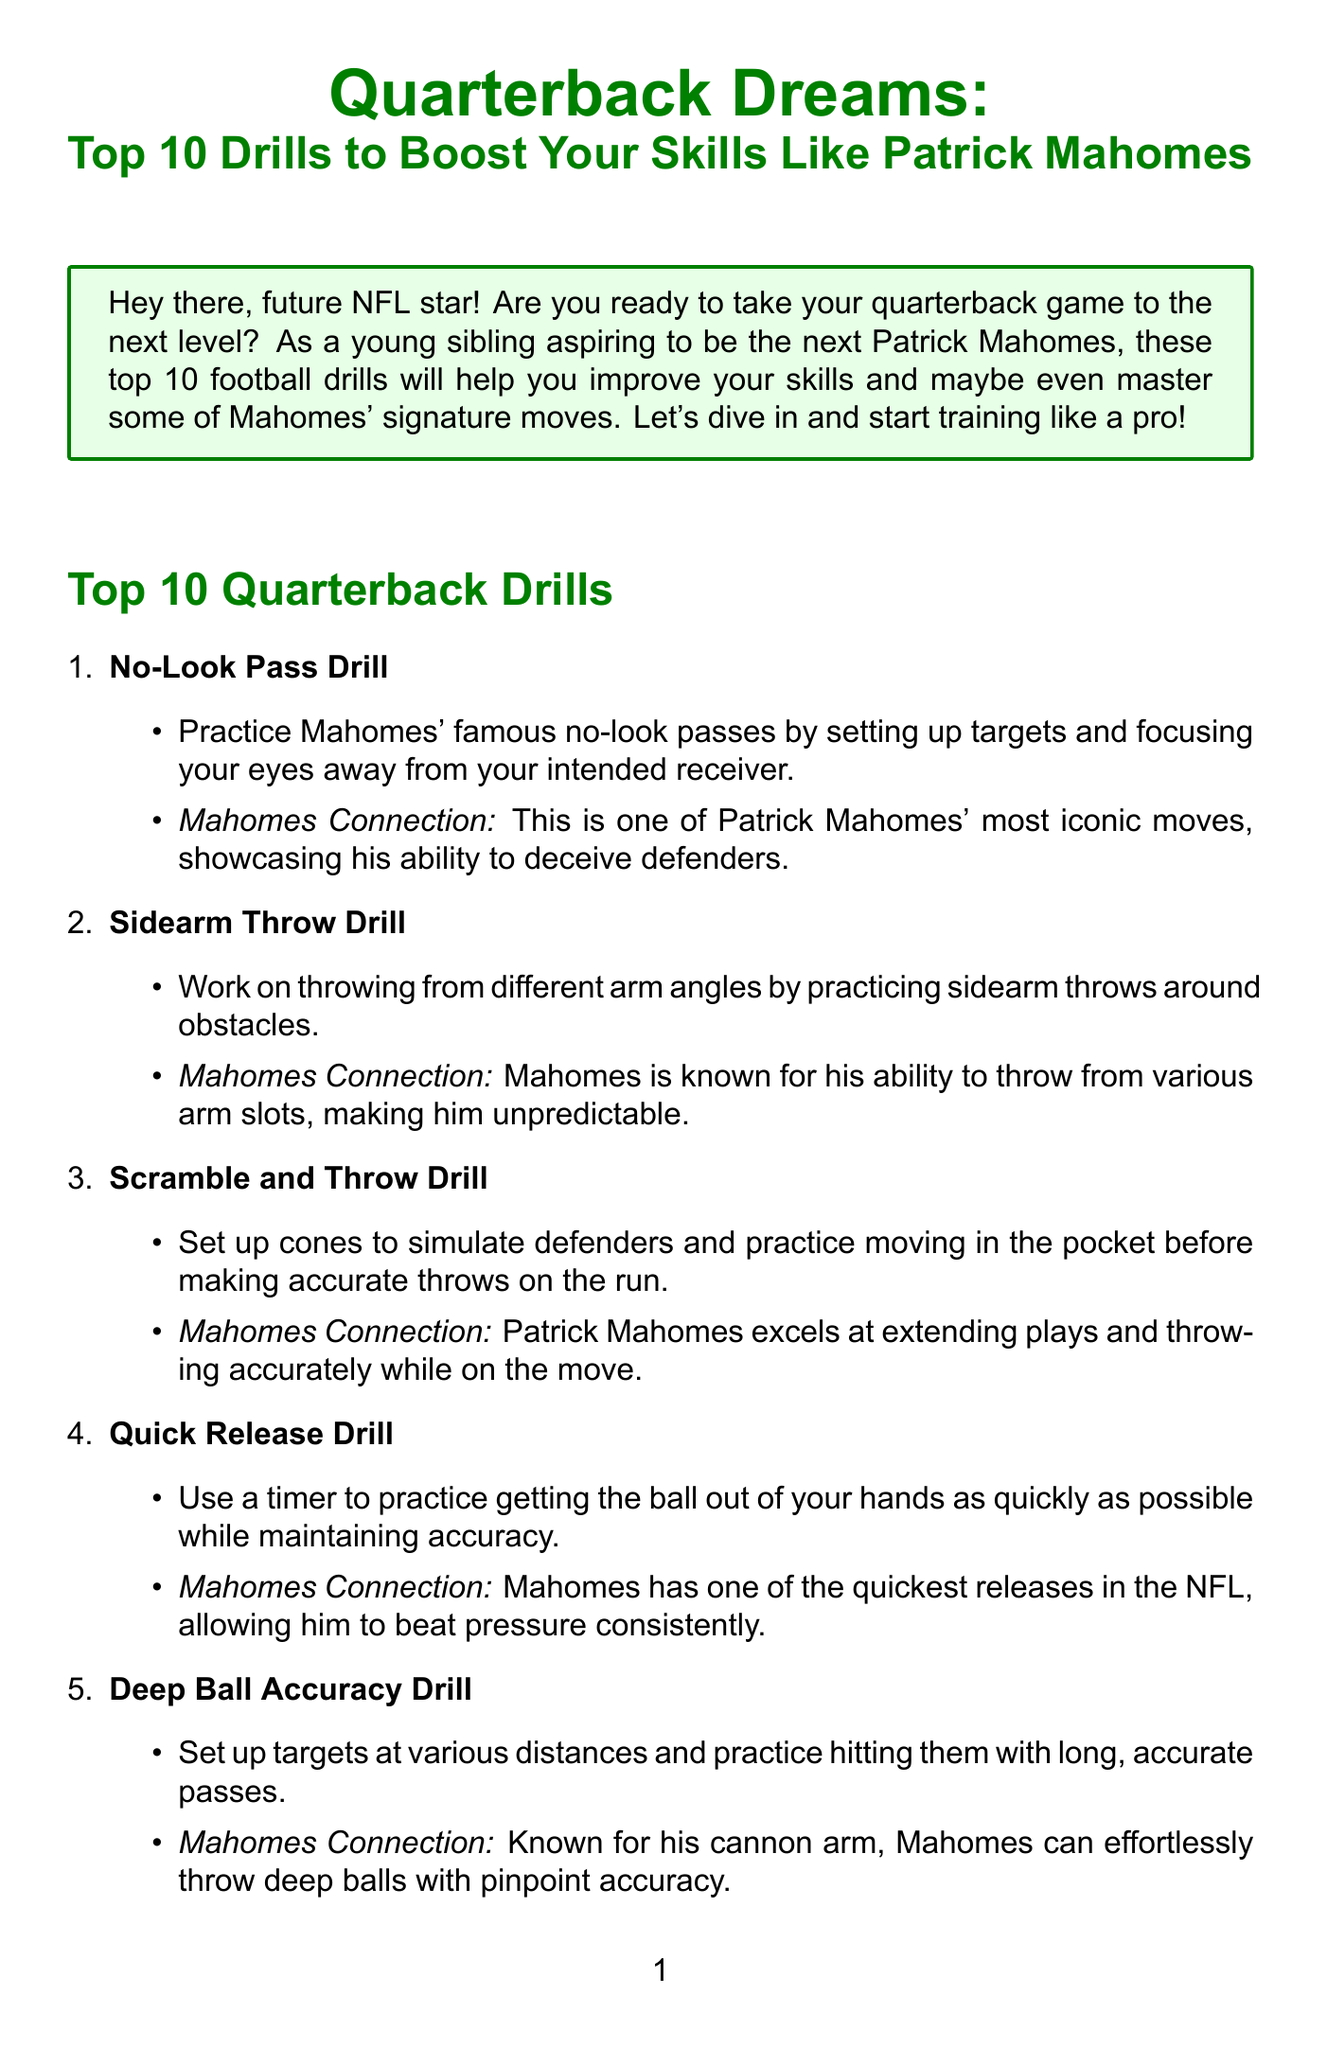What is the title of the newsletter? The title is clearly stated at the beginning of the document.
Answer: Quarterback Dreams: Top 10 Drills to Boost Your Skills Like Patrick Mahomes How many drills are listed in the document? The document states it is providing the top 10 drills, indicating the total number.
Answer: 10 What is the 'No-Look Pass Drill' aimed at practicing? The description of the drill focuses on a specific passing technique.
Answer: No-look passes Which drill is known for helping to improve arm strength? The document specifically mentions a drill focused on building throwing power.
Answer: Arm Strength Building Drill What advice is given to prevent injuries before starting drills? The document includes a precautionary measure related to warm-up practices.
Answer: Warm up properly Which quarterback’s skills do these drills aim to emulate? The introduction and content repeatedly emphasize this person's significance.
Answer: Patrick Mahomes What type of activity does the 'Jump Pass Drill' involve? The description explains the action required for this specific drill.
Answer: Jumping or leaping over obstacles What does Patrick Mahomes suggest is necessary to get better as a player? The quote at the end of the document provides insight into Mahomes' perspective.
Answer: Do a lot of different things 